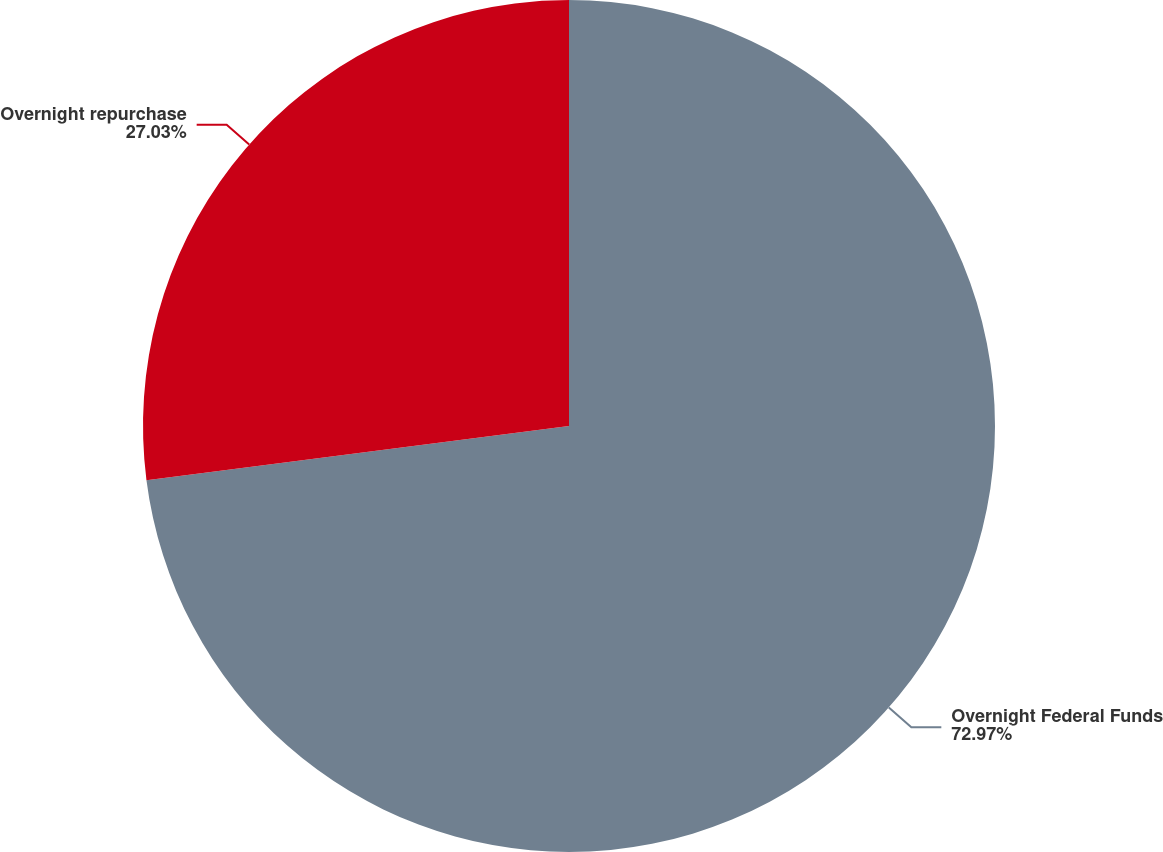Convert chart to OTSL. <chart><loc_0><loc_0><loc_500><loc_500><pie_chart><fcel>Overnight Federal Funds<fcel>Overnight repurchase<nl><fcel>72.97%<fcel>27.03%<nl></chart> 